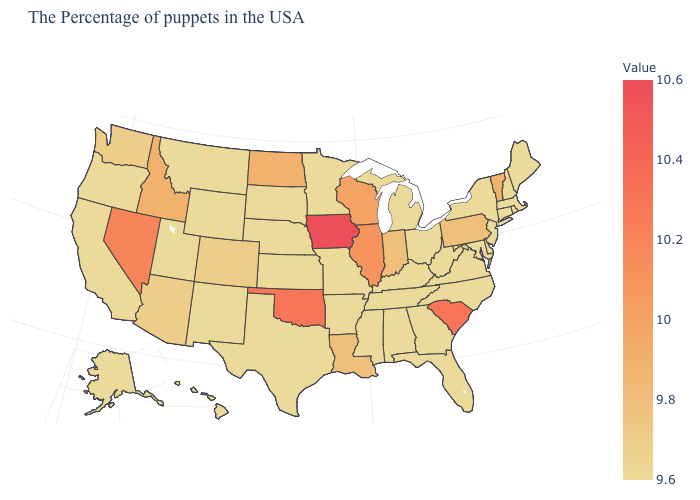Which states have the lowest value in the USA?
Keep it brief. Maine, Massachusetts, Rhode Island, New Hampshire, Connecticut, New York, New Jersey, Delaware, Maryland, Virginia, North Carolina, West Virginia, Ohio, Florida, Georgia, Michigan, Kentucky, Alabama, Tennessee, Mississippi, Missouri, Arkansas, Minnesota, Kansas, Nebraska, Texas, South Dakota, Wyoming, New Mexico, Utah, Montana, California, Oregon, Alaska, Hawaii. Among the states that border Mississippi , which have the lowest value?
Be succinct. Alabama, Tennessee, Arkansas. Which states have the lowest value in the Northeast?
Answer briefly. Maine, Massachusetts, Rhode Island, New Hampshire, Connecticut, New York, New Jersey. 